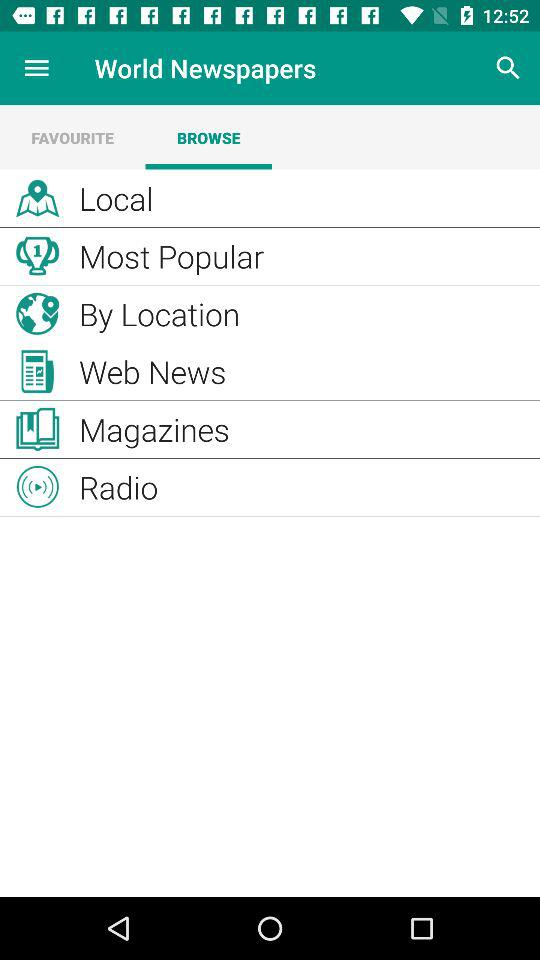What is the application name? The application name is "World Newspapers". 